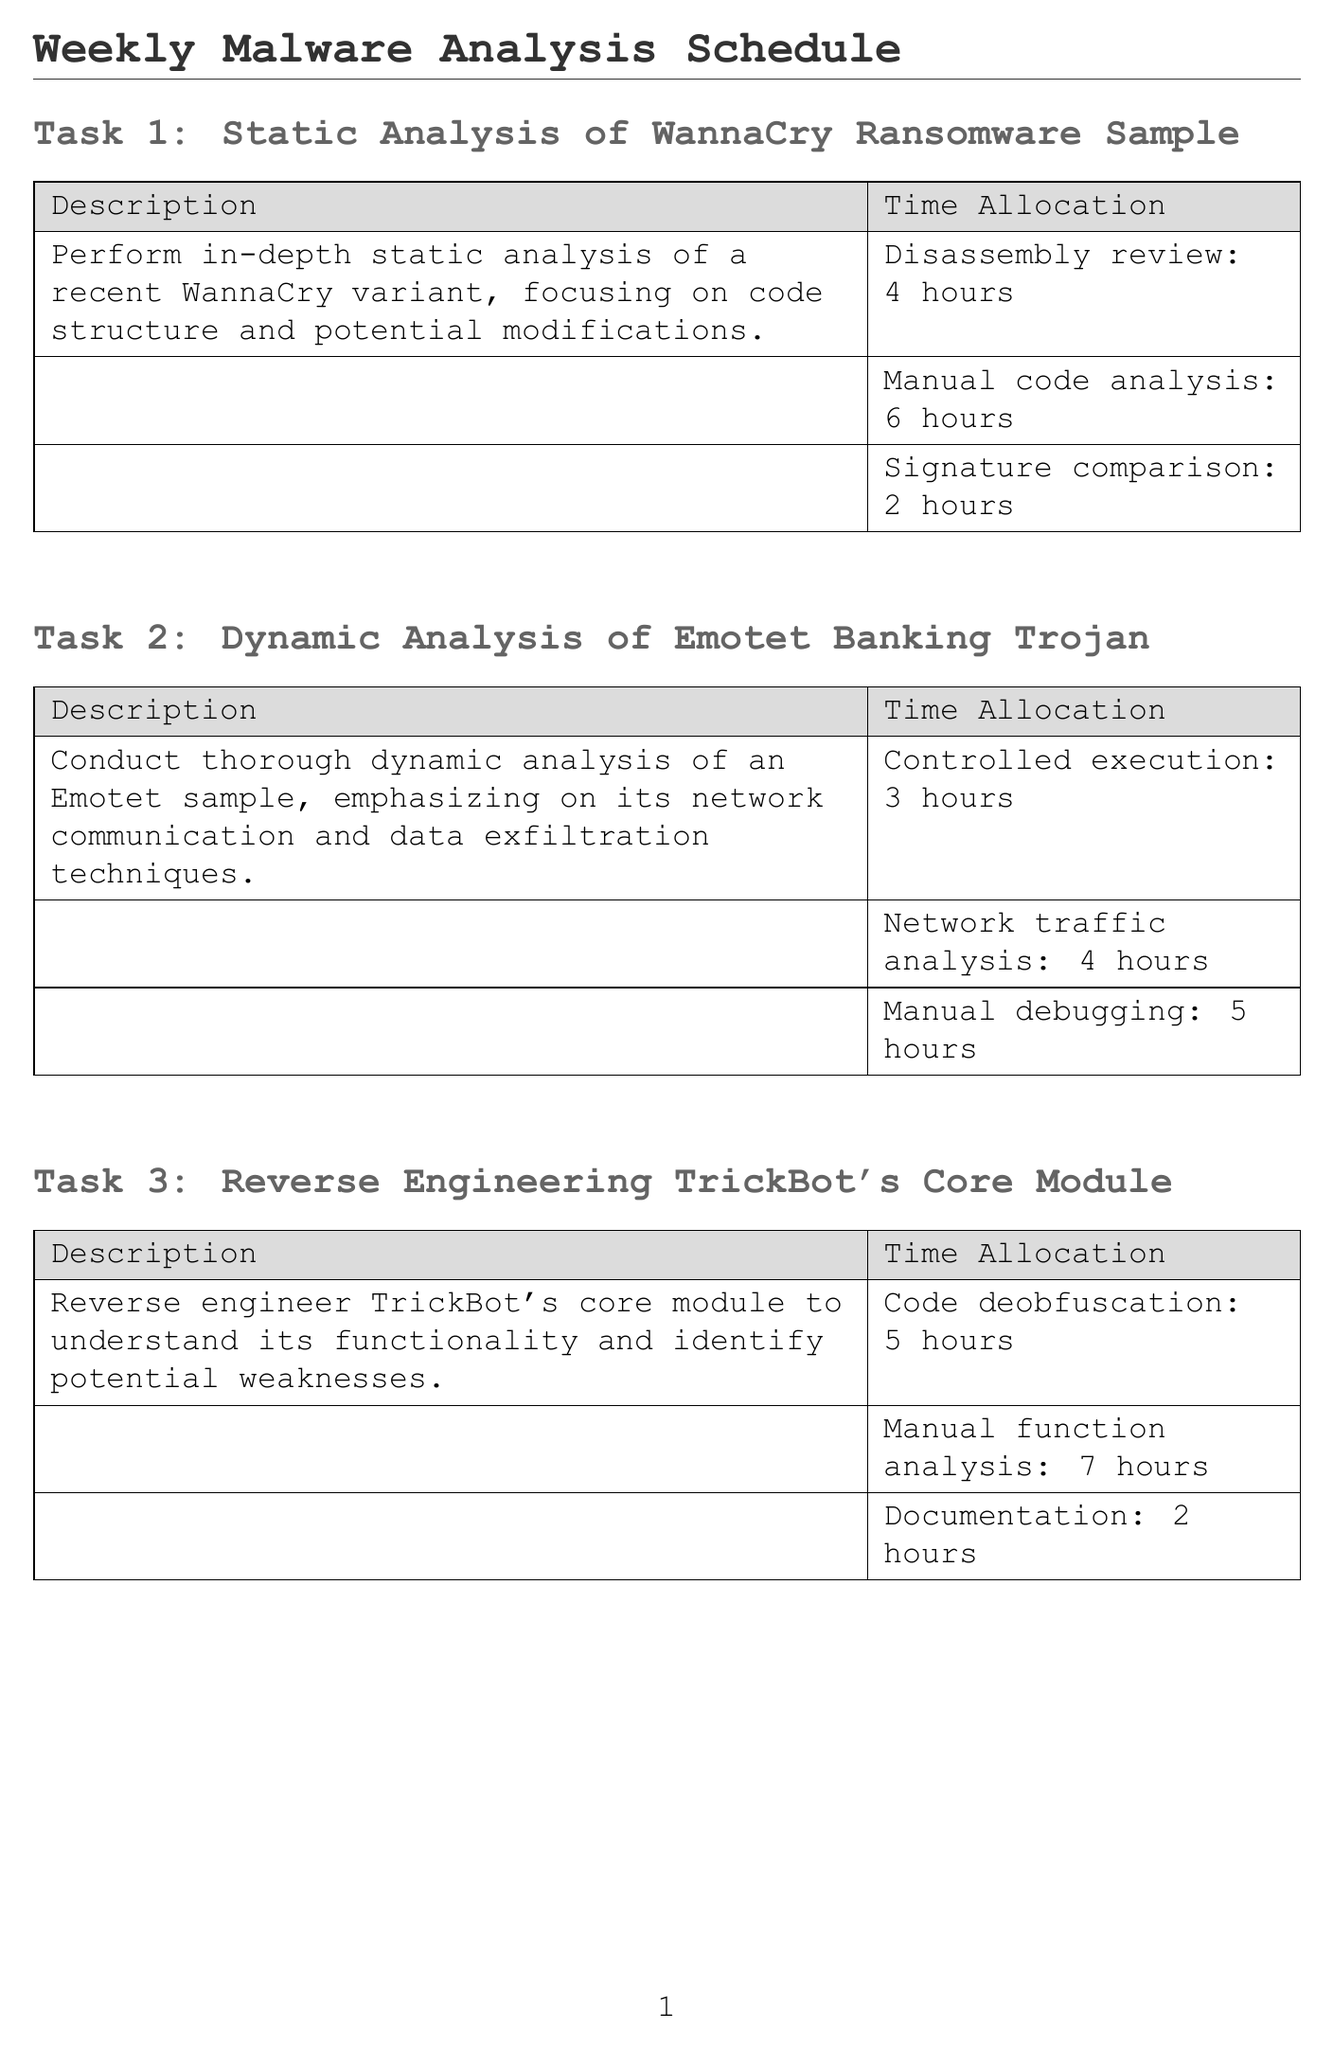what is the first task listed in the schedule? The first task in the schedule is "Static Analysis of WannaCry Ransomware Sample."
Answer: Static Analysis of WannaCry Ransomware Sample how many hours are allocated for manual debugging in the second task? The second task allocates 5 hours for manual debugging.
Answer: 5 hours what tool is used for the manual code review in the fifth task? The tools listed for the fifth task include VMware Workstation, Procmon, and Regshot, with the review being manual.
Answer: VMware Workstation what is the total time allocated for the third task's manual function analysis and documentation? The total time combines 7 hours for manual function analysis and 2 hours for documentation, totaling 9 hours.
Answer: 9 hours how many hours are allocated for controlled execution in the fourth task? The document specifies that there are 4 hours allocated for controlled execution.
Answer: 4 hours which task involves the analysis of a Qakbot sample? The fourth task listed focuses on extracting and analyzing the configuration of a Qakbot sample.
Answer: Malware Configuration Extraction for Qakbot what task follows the dynamic analysis of Emotet Banking Trojan? The task that follows is "Reverse Engineering TrickBot's Core Module."
Answer: Reverse Engineering TrickBot's Core Module which aspect is emphasized in the behavioral analysis of Ryuk ransomware? The emphasis is on the file encryption routines and system modifications.
Answer: File encryption routines and system modifications 